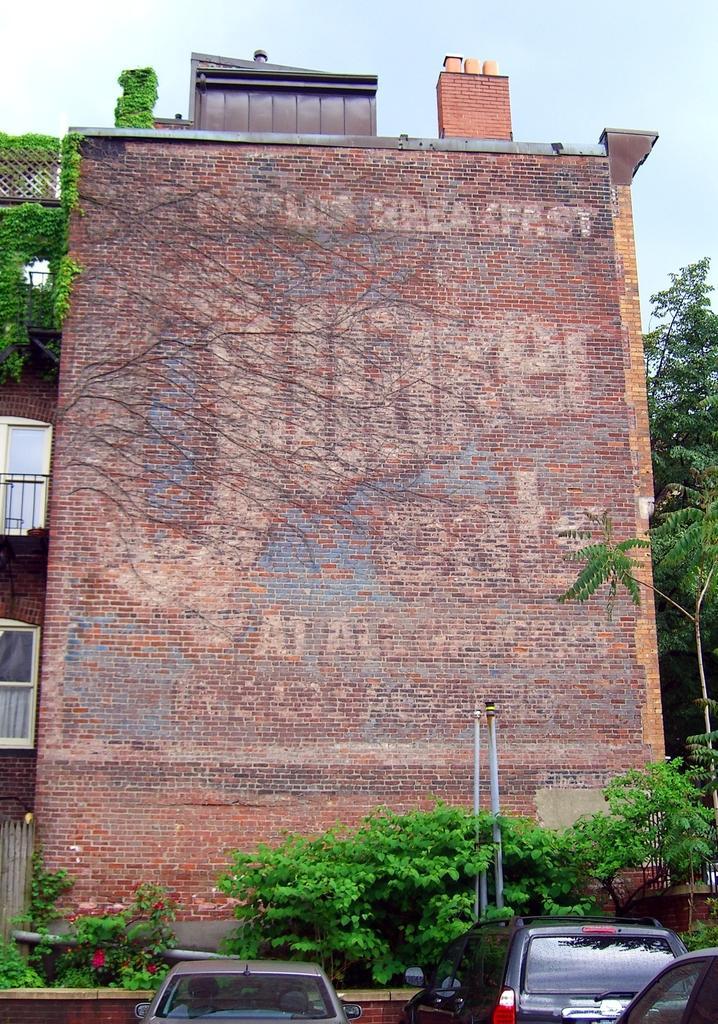In one or two sentences, can you explain what this image depicts? In this image we can see the building, creepers, plants, pipes and also the trees. We can also see the sky. At the bottom we can see the vehicles. 